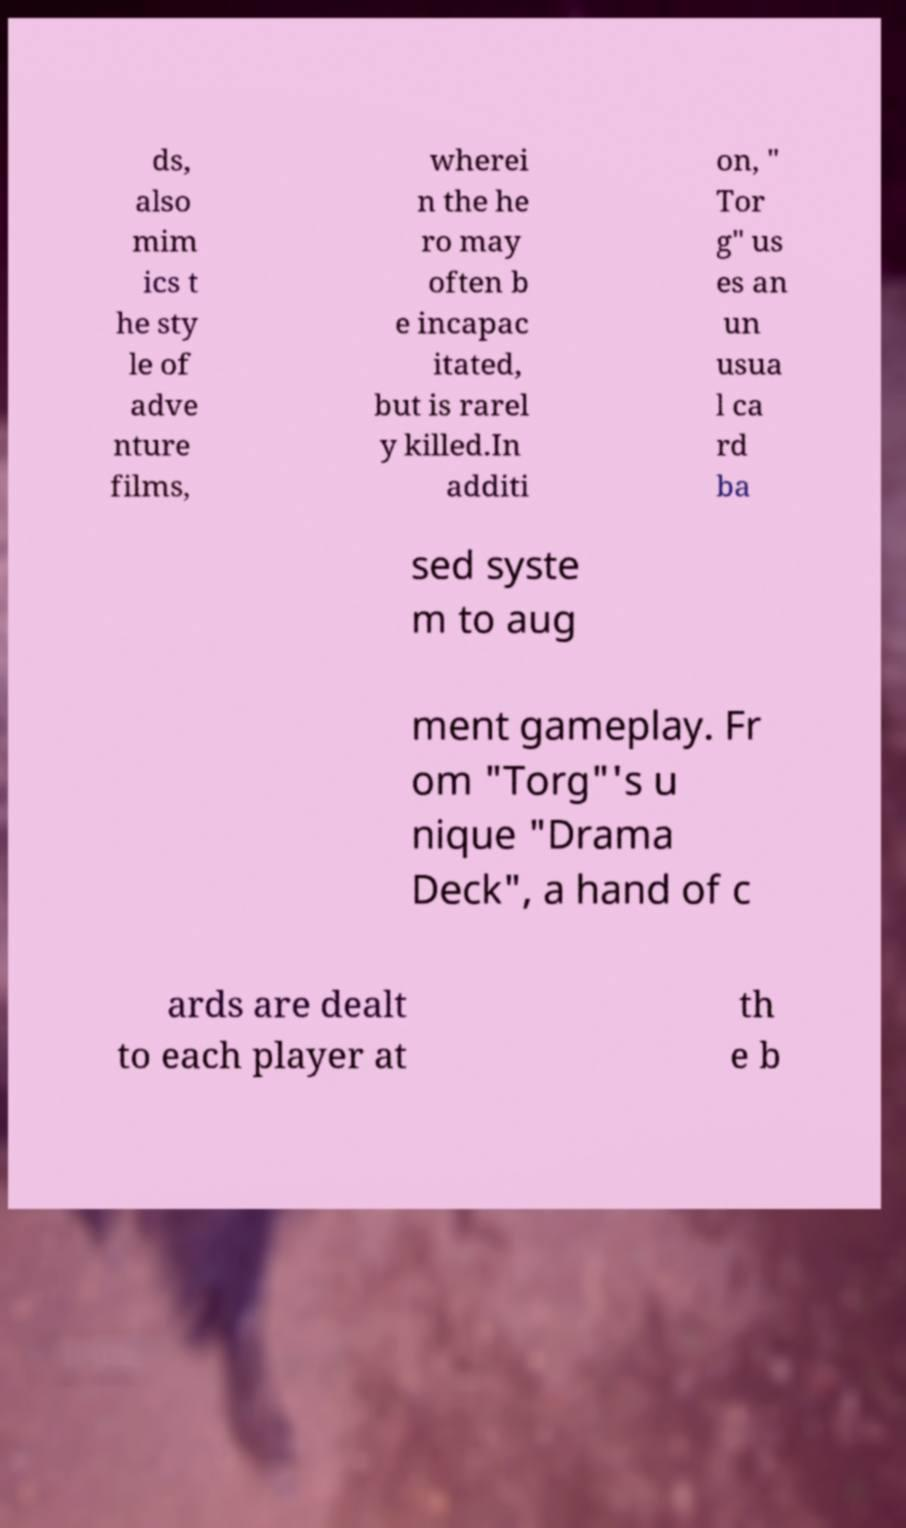Could you extract and type out the text from this image? ds, also mim ics t he sty le of adve nture films, wherei n the he ro may often b e incapac itated, but is rarel y killed.In additi on, " Tor g" us es an un usua l ca rd ba sed syste m to aug ment gameplay. Fr om "Torg"'s u nique "Drama Deck", a hand of c ards are dealt to each player at th e b 